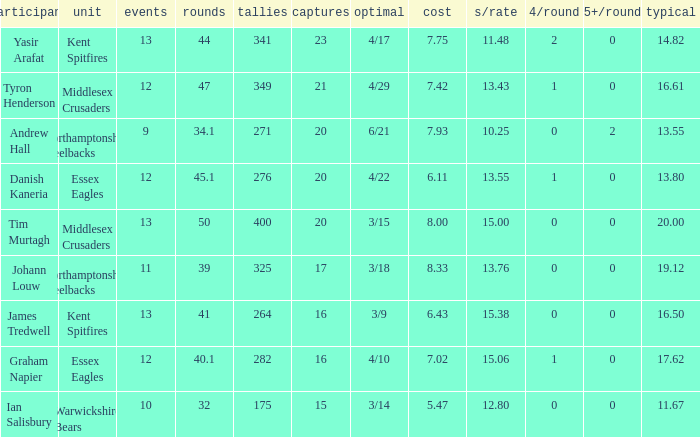Help me parse the entirety of this table. {'header': ['participant', 'unit', 'events', 'rounds', 'tallies', 'captures', 'optimal', 'cost', 's/rate', '4/round', '5+/round', 'typical'], 'rows': [['Yasir Arafat', 'Kent Spitfires', '13', '44', '341', '23', '4/17', '7.75', '11.48', '2', '0', '14.82'], ['Tyron Henderson', 'Middlesex Crusaders', '12', '47', '349', '21', '4/29', '7.42', '13.43', '1', '0', '16.61'], ['Andrew Hall', 'Northamptonshire Steelbacks', '9', '34.1', '271', '20', '6/21', '7.93', '10.25', '0', '2', '13.55'], ['Danish Kaneria', 'Essex Eagles', '12', '45.1', '276', '20', '4/22', '6.11', '13.55', '1', '0', '13.80'], ['Tim Murtagh', 'Middlesex Crusaders', '13', '50', '400', '20', '3/15', '8.00', '15.00', '0', '0', '20.00'], ['Johann Louw', 'Northamptonshire Steelbacks', '11', '39', '325', '17', '3/18', '8.33', '13.76', '0', '0', '19.12'], ['James Tredwell', 'Kent Spitfires', '13', '41', '264', '16', '3/9', '6.43', '15.38', '0', '0', '16.50'], ['Graham Napier', 'Essex Eagles', '12', '40.1', '282', '16', '4/10', '7.02', '15.06', '1', '0', '17.62'], ['Ian Salisbury', 'Warwickshire Bears', '10', '32', '175', '15', '3/14', '5.47', '12.80', '0', '0', '11.67']]} Name the most 4/inns 2.0. 